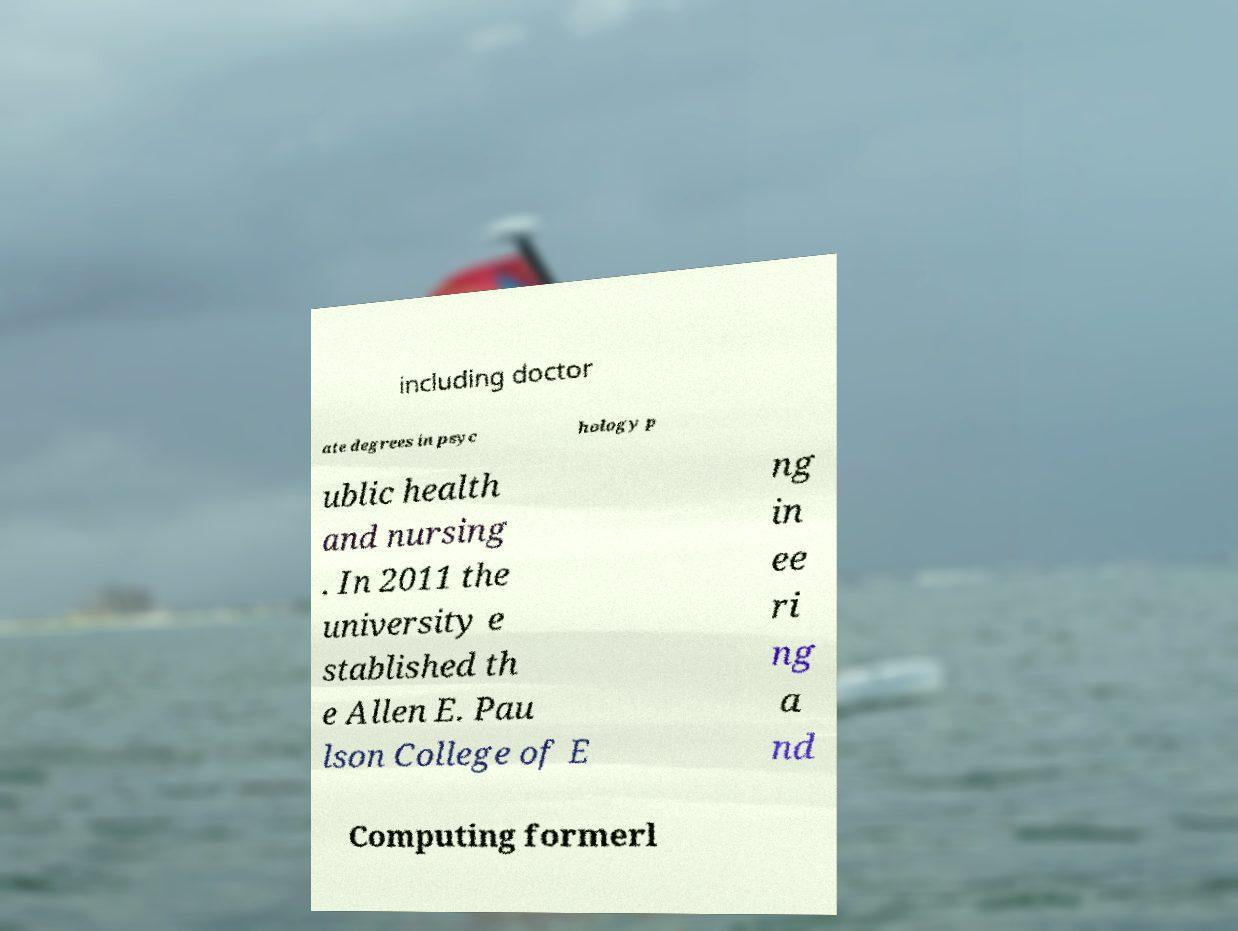Can you read and provide the text displayed in the image?This photo seems to have some interesting text. Can you extract and type it out for me? including doctor ate degrees in psyc hology p ublic health and nursing . In 2011 the university e stablished th e Allen E. Pau lson College of E ng in ee ri ng a nd Computing formerl 